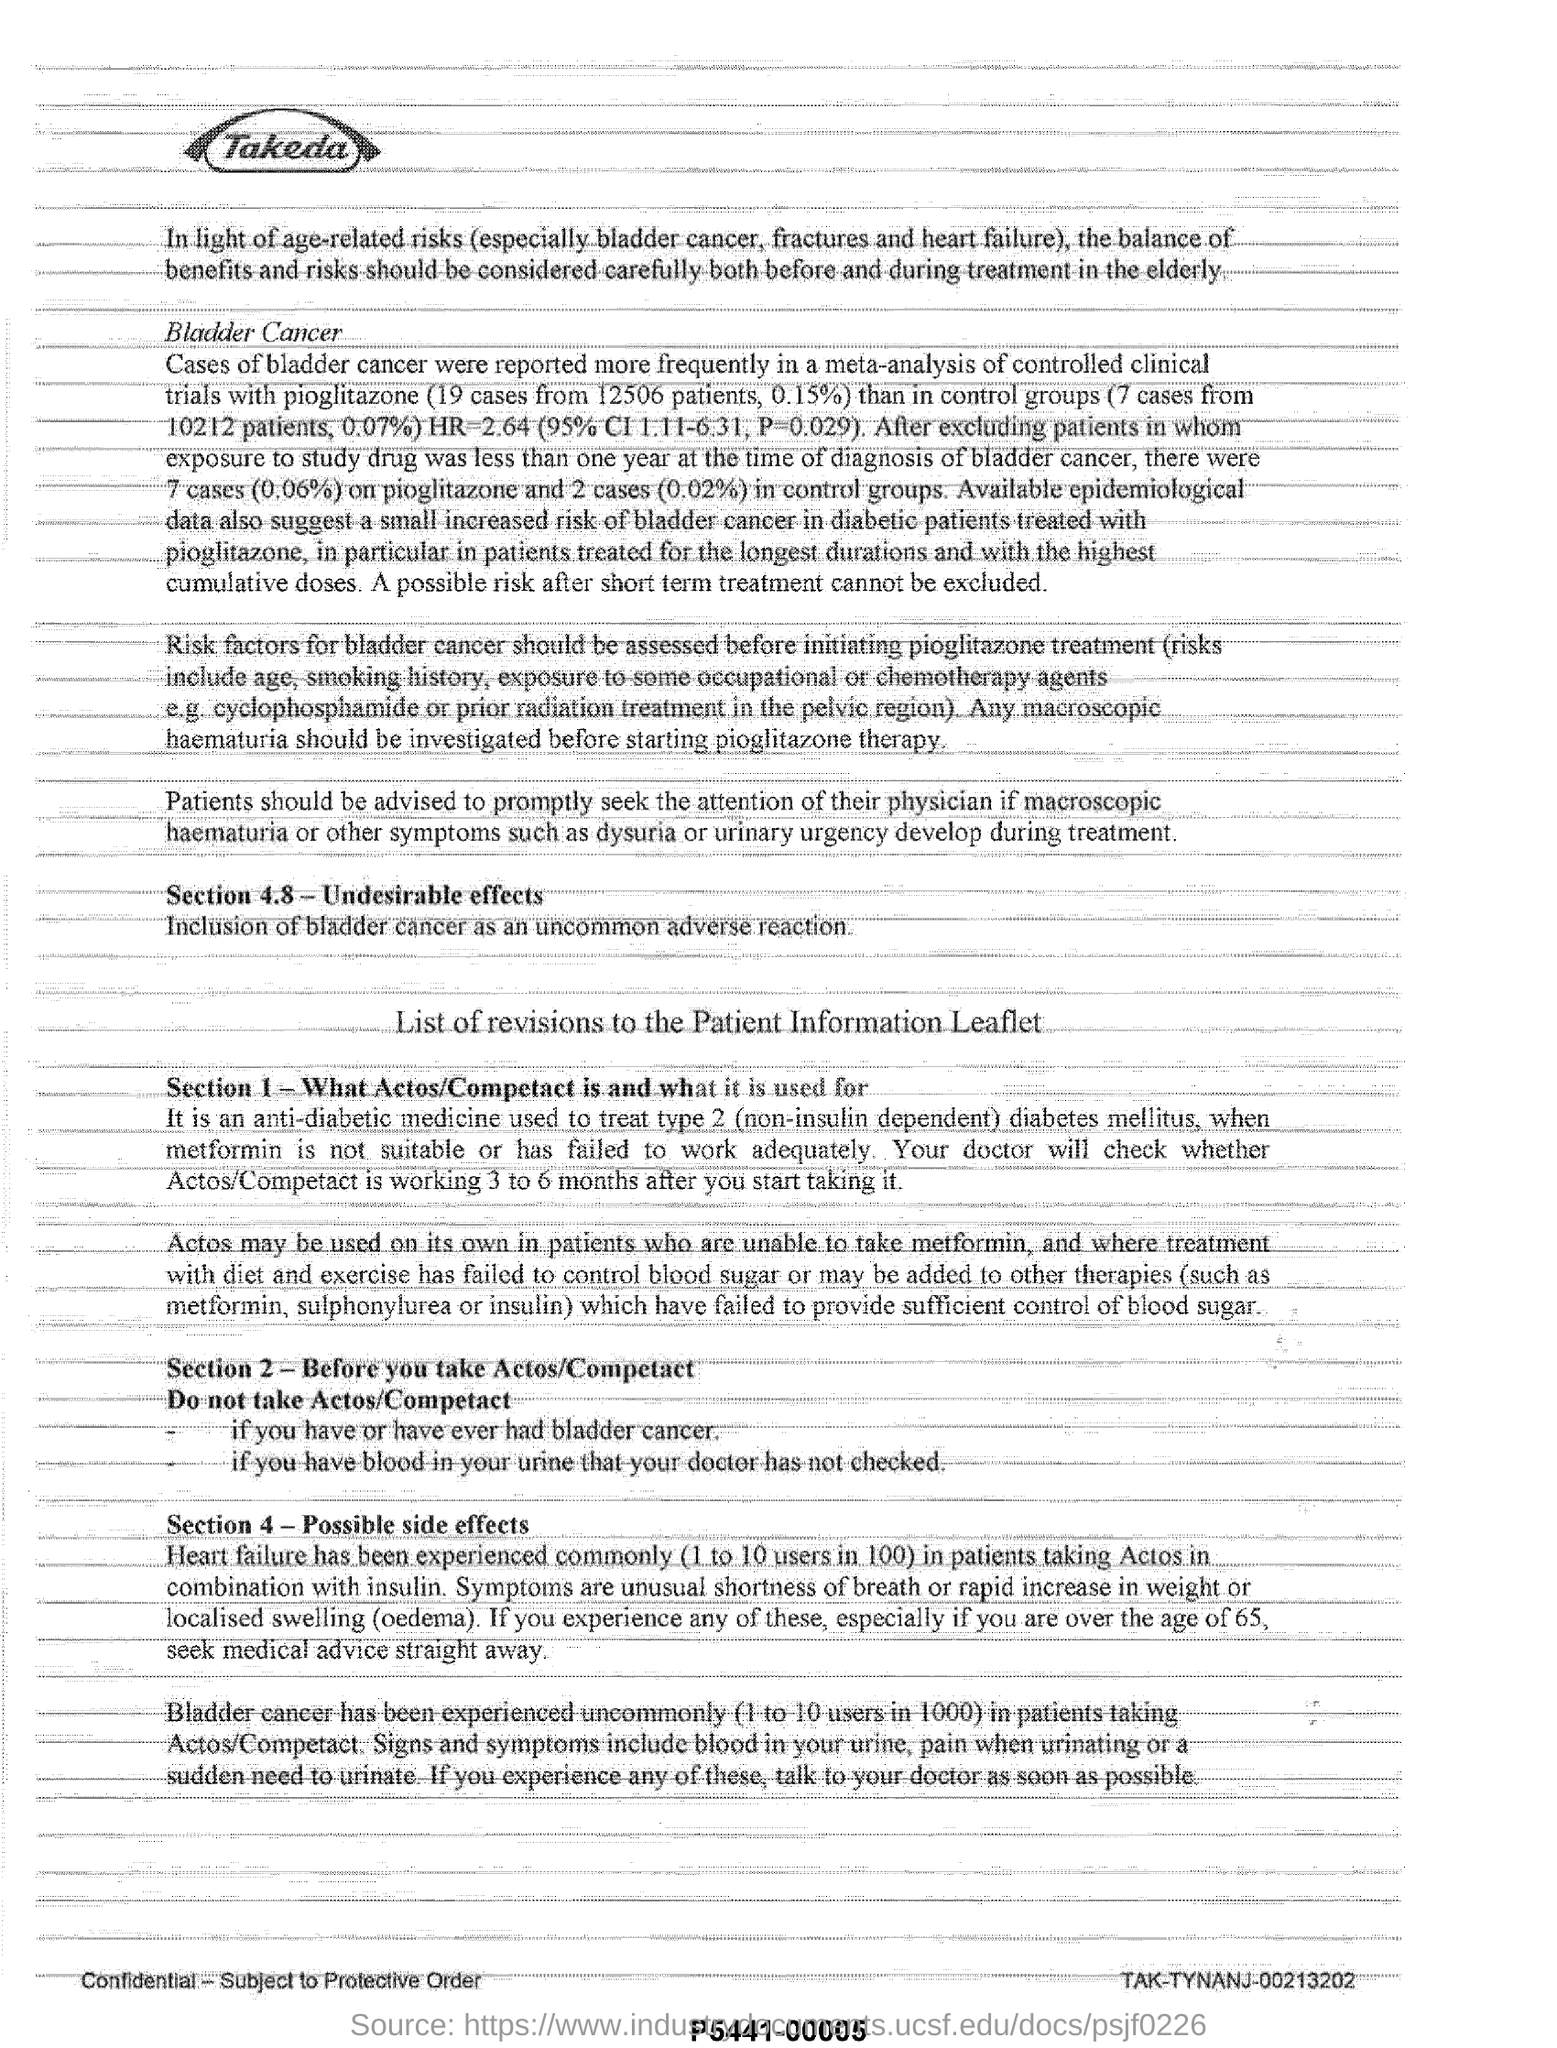Indicate a few pertinent items in this graphic. Before initiating pioglitazone therapy, it is necessary to investigate whether there is any macroscopic haematuria present. It has been reported that patients who take Actos in combination with insulin may commonly experience heart failure. In total, 12506 patients were reported to have bladder cancer, and out of those patients, 19 cases were reported. Actos/Competact is a medication used to treat type 2 diabetes mellitus. 